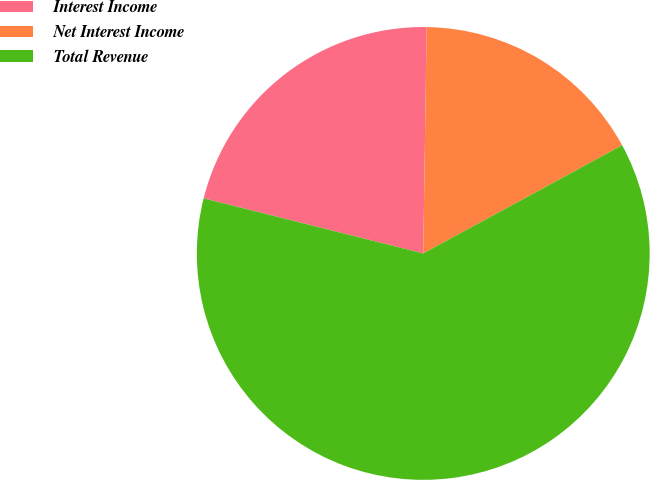<chart> <loc_0><loc_0><loc_500><loc_500><pie_chart><fcel>Interest Income<fcel>Net Interest Income<fcel>Total Revenue<nl><fcel>21.33%<fcel>16.83%<fcel>61.84%<nl></chart> 